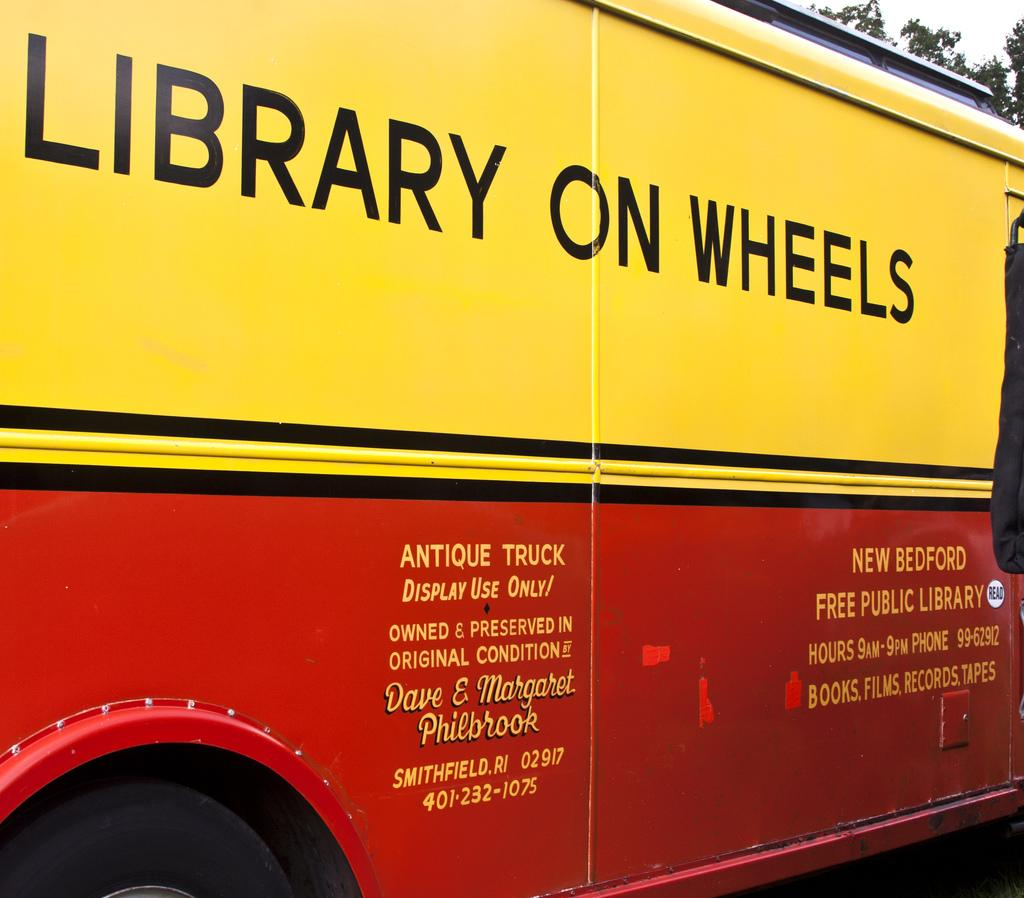What is the main subject in the center of the image? There is a bus in the center of the image. What can be seen on the bus? There is text written on the bus. What type of natural scenery is visible in the background of the image? There are trees in the background of the image. Is there a train going up a hill in the north direction in the image? No, there is no train, hill, or north direction mentioned in the image. The image only features a bus with text and trees in the background. 